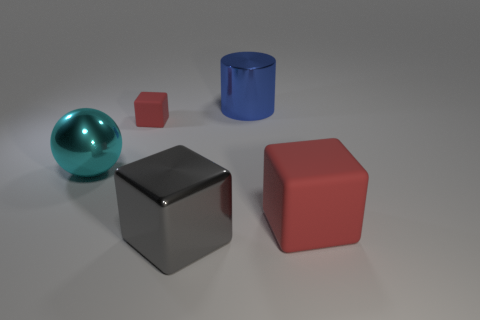What number of objects are large green metal balls or cubes?
Your answer should be compact. 3. What number of cyan things have the same material as the large cylinder?
Make the answer very short. 1. There is another red thing that is the same shape as the big red thing; what is its size?
Provide a succinct answer. Small. There is a large matte object; are there any small red things in front of it?
Offer a very short reply. No. What is the large blue cylinder made of?
Make the answer very short. Metal. There is a big metallic cylinder that is behind the cyan metal object; is its color the same as the large sphere?
Provide a succinct answer. No. Is there anything else that has the same shape as the big blue shiny object?
Offer a terse response. No. There is another big shiny thing that is the same shape as the big red thing; what is its color?
Offer a very short reply. Gray. There is a red cube left of the big shiny cylinder; what material is it?
Offer a very short reply. Rubber. What color is the large rubber cube?
Provide a succinct answer. Red. 